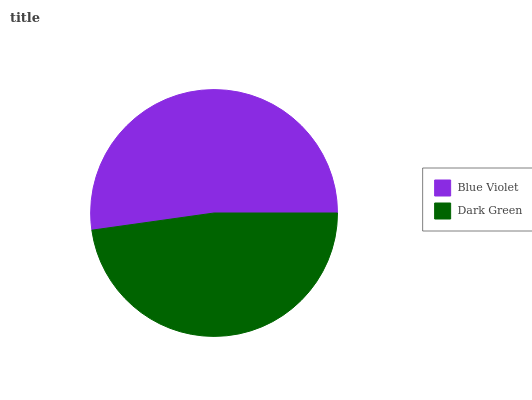Is Dark Green the minimum?
Answer yes or no. Yes. Is Blue Violet the maximum?
Answer yes or no. Yes. Is Dark Green the maximum?
Answer yes or no. No. Is Blue Violet greater than Dark Green?
Answer yes or no. Yes. Is Dark Green less than Blue Violet?
Answer yes or no. Yes. Is Dark Green greater than Blue Violet?
Answer yes or no. No. Is Blue Violet less than Dark Green?
Answer yes or no. No. Is Blue Violet the high median?
Answer yes or no. Yes. Is Dark Green the low median?
Answer yes or no. Yes. Is Dark Green the high median?
Answer yes or no. No. Is Blue Violet the low median?
Answer yes or no. No. 